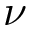<formula> <loc_0><loc_0><loc_500><loc_500>\nu</formula> 